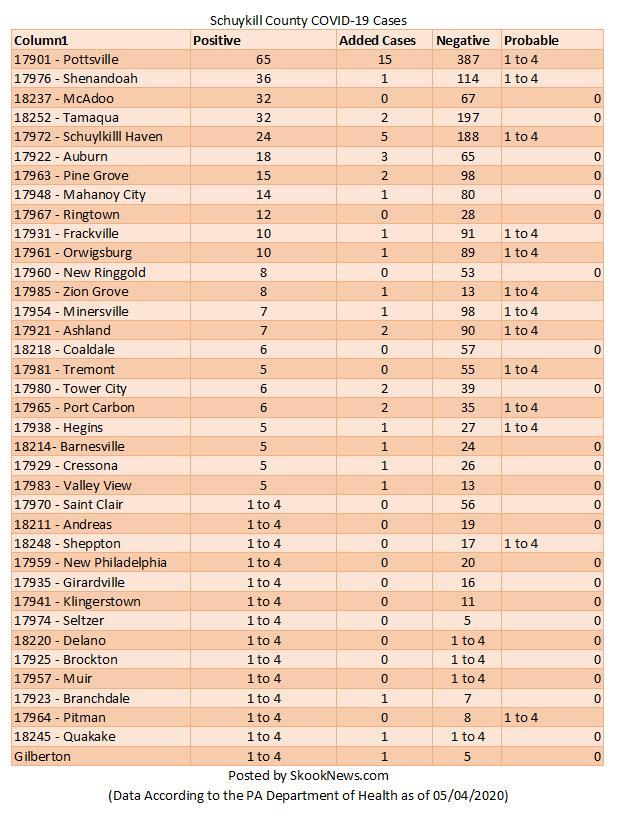What is the number of Covid positive cases reported in Ashland as of 05/04/2020?
Answer the question with a short phrase. 7 What is the number of Covid negative cases reported in Port Carbon as of 05/04/2020? 35 How many new cases of Covid-19 were added in Tamaqua as of 05/04/2020? 2 What is the number of Covid positive cases reported in Ringtown as of 05/04/2020? 12 What is the number of Covid negative cases reported in Valley View as of 05/04/2020? 1 How many new cases of Covid-19 were added in Auburn as of 05/04/2020? 3 